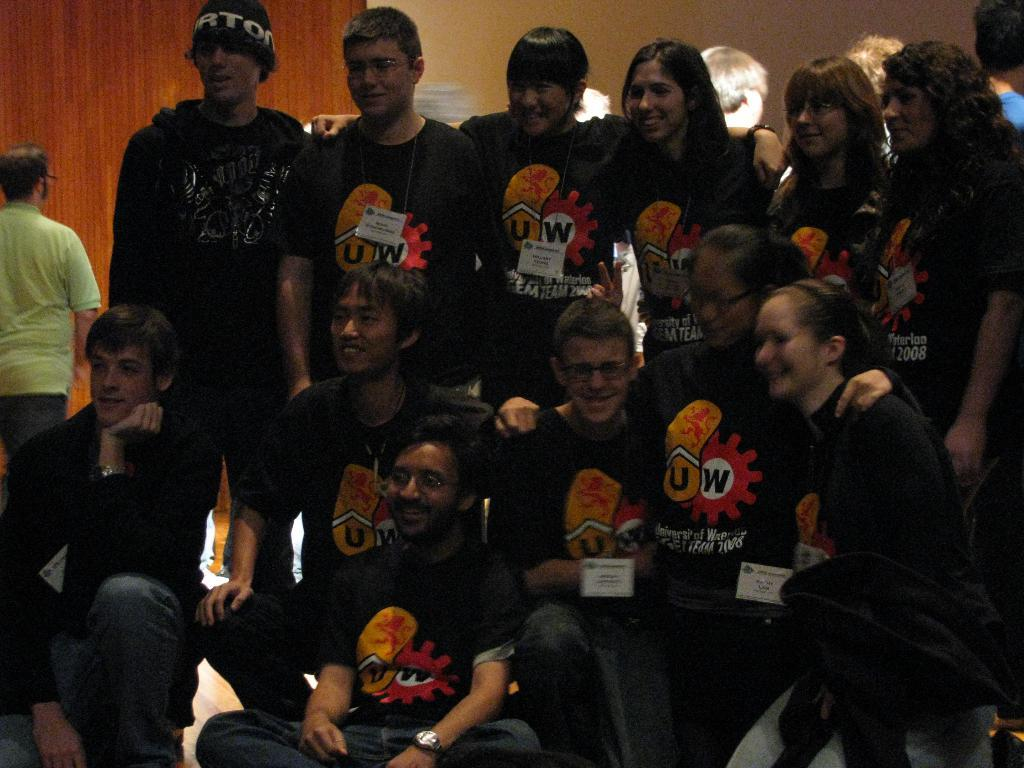Who is present in the image? There are people in the image. What are the people wearing? The people are wearing black t-shirts. What are the people doing in the image? The people are posing for a photo. Can you describe the background of the image? There is a wall in the background of the image. Are there any other activities happening in the image? Yes, there is a person walking in the image. What month is the song mentioned in the image? There is no mention of a song or a specific month in the image. 